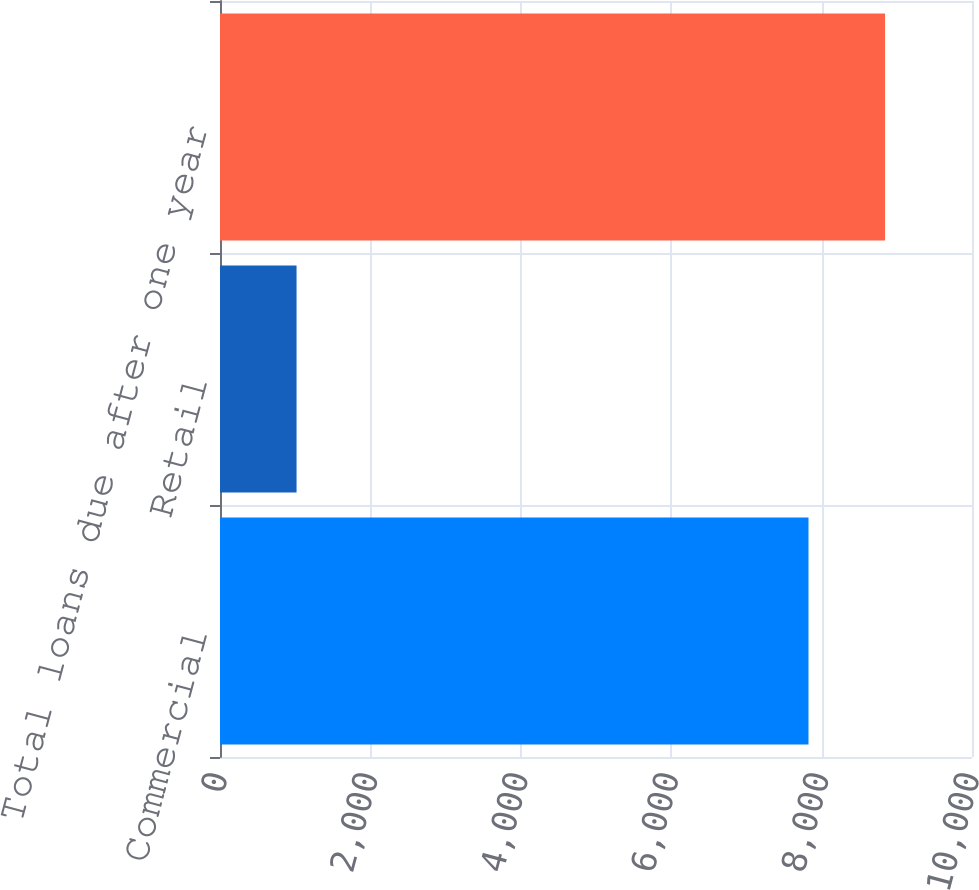Convert chart to OTSL. <chart><loc_0><loc_0><loc_500><loc_500><bar_chart><fcel>Commercial<fcel>Retail<fcel>Total loans due after one year<nl><fcel>7825.8<fcel>1018<fcel>8843.8<nl></chart> 